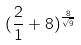Convert formula to latex. <formula><loc_0><loc_0><loc_500><loc_500>( \frac { 2 } { 1 } + 8 ) ^ { \frac { 8 } { \sqrt { 9 } } }</formula> 